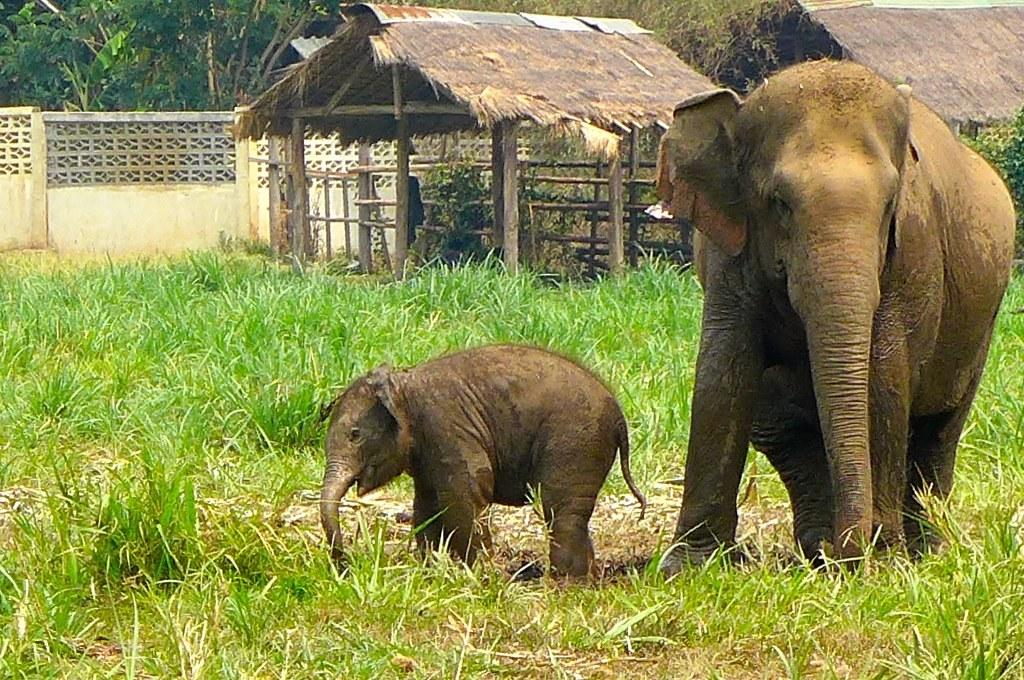What animal can be seen in the image? There is an elephant in the image. Is there a baby elephant with the adult elephant? Yes, there is a calf with the elephant. What type of vegetation is present on the ground in the image? There is grass on the ground in the image. What other natural elements can be seen in the image? There are trees in the image. What type of structures are visible in the background of the image? There are huts in the background of the image. What man-made object is visible in the image? There is a wall visible in the image. What type of degree is the elephant pursuing in the image? There is no indication in the image that the elephant is pursuing a degree. Can you see any celery in the image? There is no celery present in the image. 